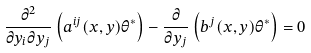<formula> <loc_0><loc_0><loc_500><loc_500>\frac { \partial ^ { 2 } } { \partial y _ { i } \partial y _ { j } } \left ( a ^ { i j } ( x , y ) \theta ^ { \ast } \right ) - \frac { \partial } { \partial y _ { j } } \left ( b ^ { j } ( x , y ) \theta ^ { \ast } \right ) = 0</formula> 